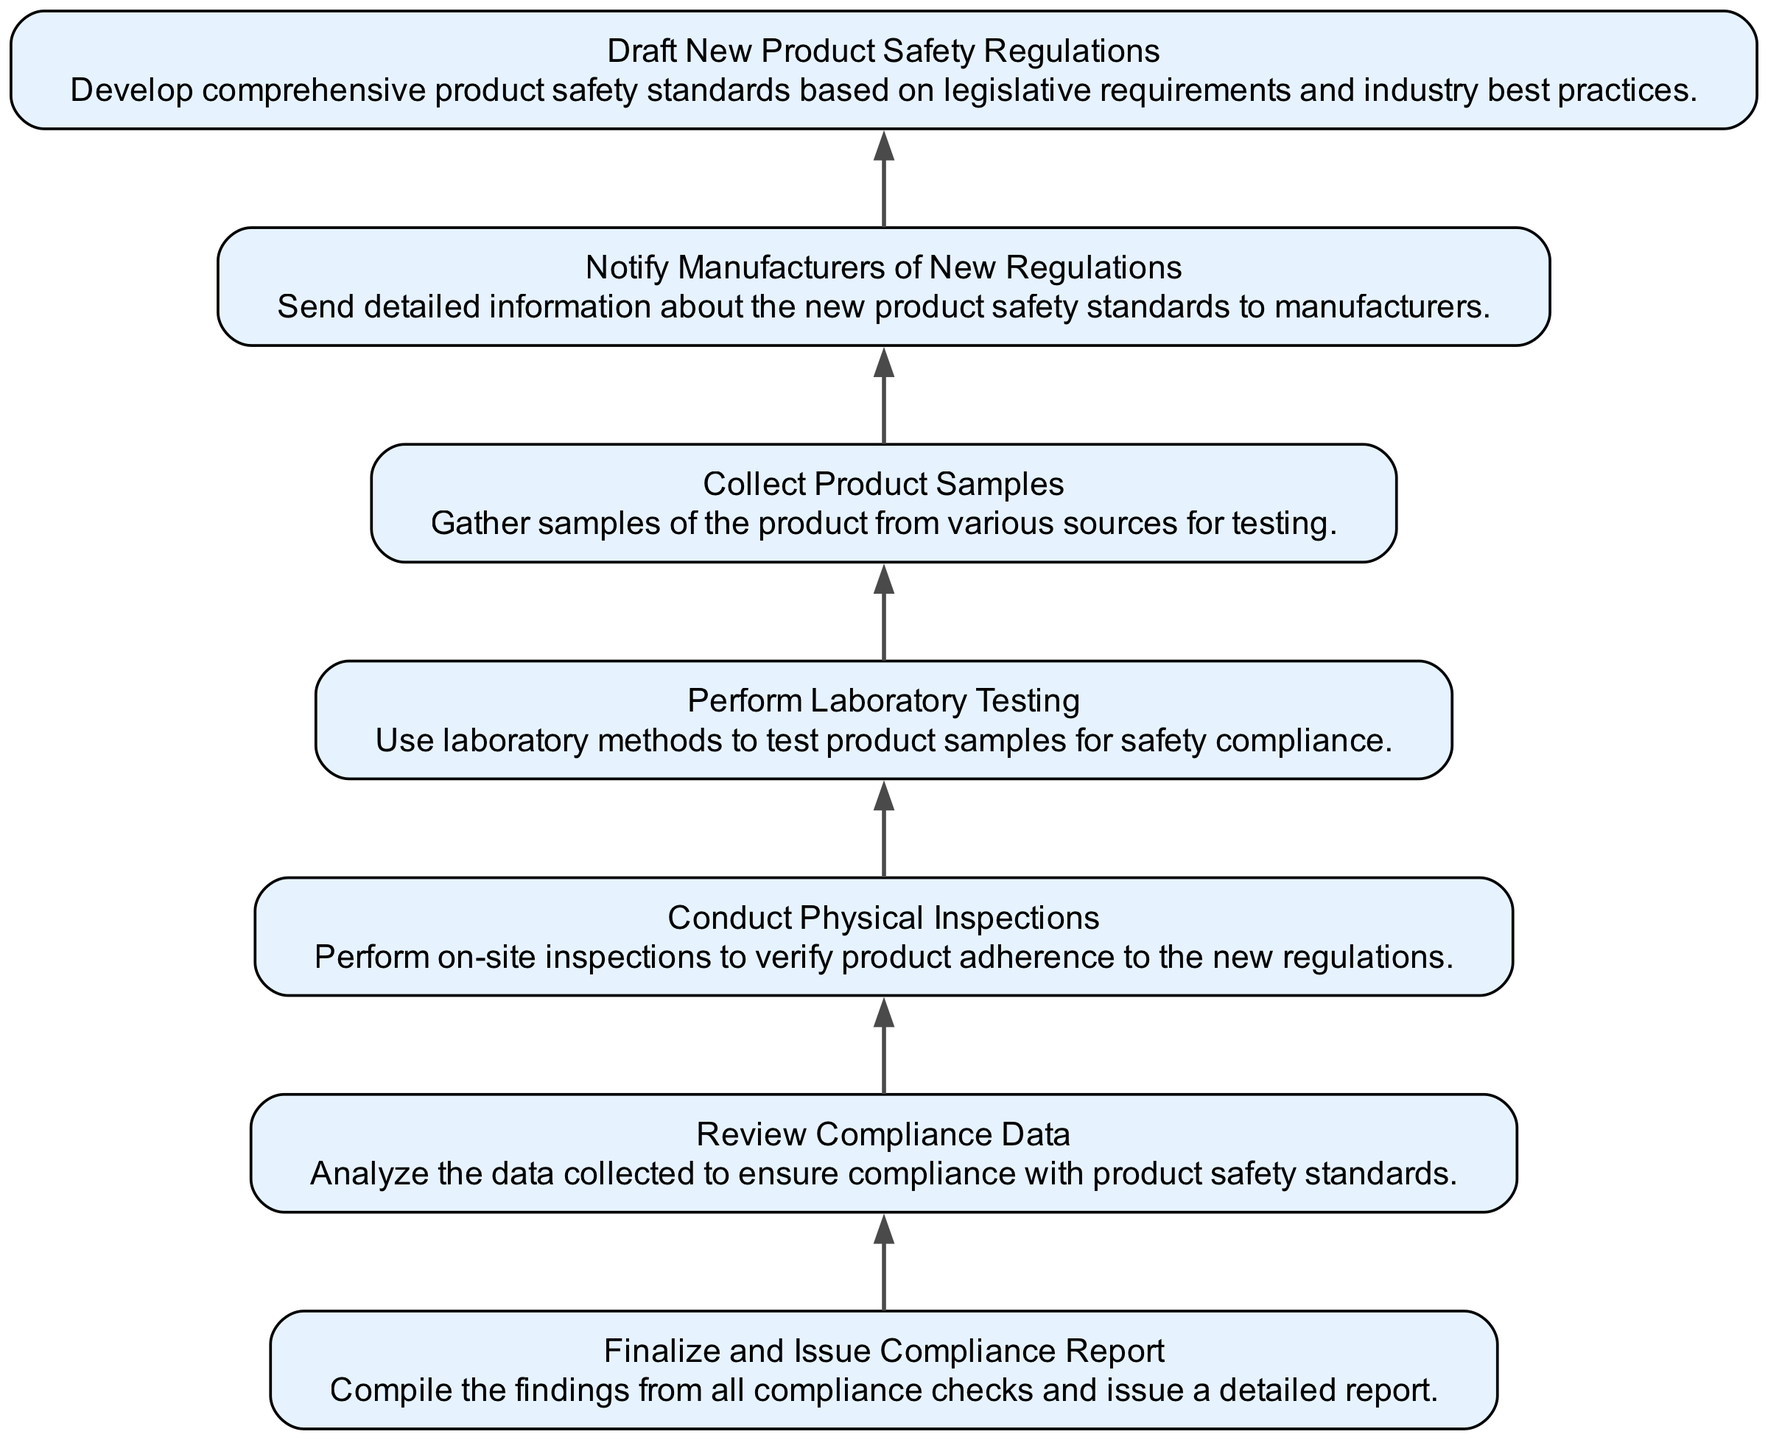What is the final step in the compliance checks process? The final step in the compliance checks process is represented by the last node in the diagram, which is "Finalize and Issue Compliance Report."
Answer: Finalize and Issue Compliance Report How many nodes are in the diagram? The diagram features a total of 7 nodes, each representing a different stage in the compliance checks process.
Answer: 7 What action comes immediately after "Notify Manufacturers of New Regulations"? The action that follows "Notify Manufacturers of New Regulations" is "Draft New Product Safety Regulations," as indicated by the flow direction in the diagram.
Answer: Draft New Product Safety Regulations What is the purpose of "Conduct Physical Inspections"? The purpose of "Conduct Physical Inspections" is to verify product adherence to the new regulations through on-site assessments.
Answer: Verify product adherence Which step involves laboratory methods? The step that specifically involves laboratory methods is "Perform Laboratory Testing," where product samples are tested for safety compliance.
Answer: Perform Laboratory Testing How does "Collect Product Samples" relate to "Perform Laboratory Testing"? "Collect Product Samples" comes sequentially before "Perform Laboratory Testing," indicating that samples need to be gathered prior to conducting tests on them.
Answer: Samples need to be gathered before testing 